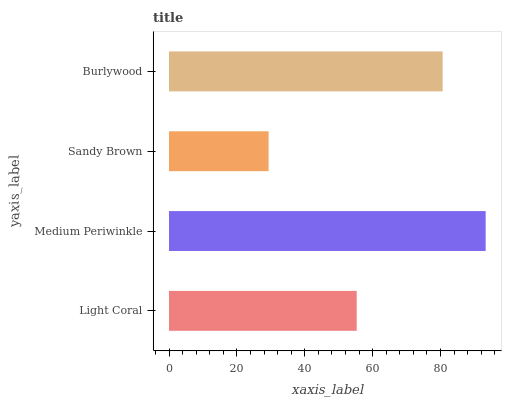Is Sandy Brown the minimum?
Answer yes or no. Yes. Is Medium Periwinkle the maximum?
Answer yes or no. Yes. Is Medium Periwinkle the minimum?
Answer yes or no. No. Is Sandy Brown the maximum?
Answer yes or no. No. Is Medium Periwinkle greater than Sandy Brown?
Answer yes or no. Yes. Is Sandy Brown less than Medium Periwinkle?
Answer yes or no. Yes. Is Sandy Brown greater than Medium Periwinkle?
Answer yes or no. No. Is Medium Periwinkle less than Sandy Brown?
Answer yes or no. No. Is Burlywood the high median?
Answer yes or no. Yes. Is Light Coral the low median?
Answer yes or no. Yes. Is Light Coral the high median?
Answer yes or no. No. Is Sandy Brown the low median?
Answer yes or no. No. 